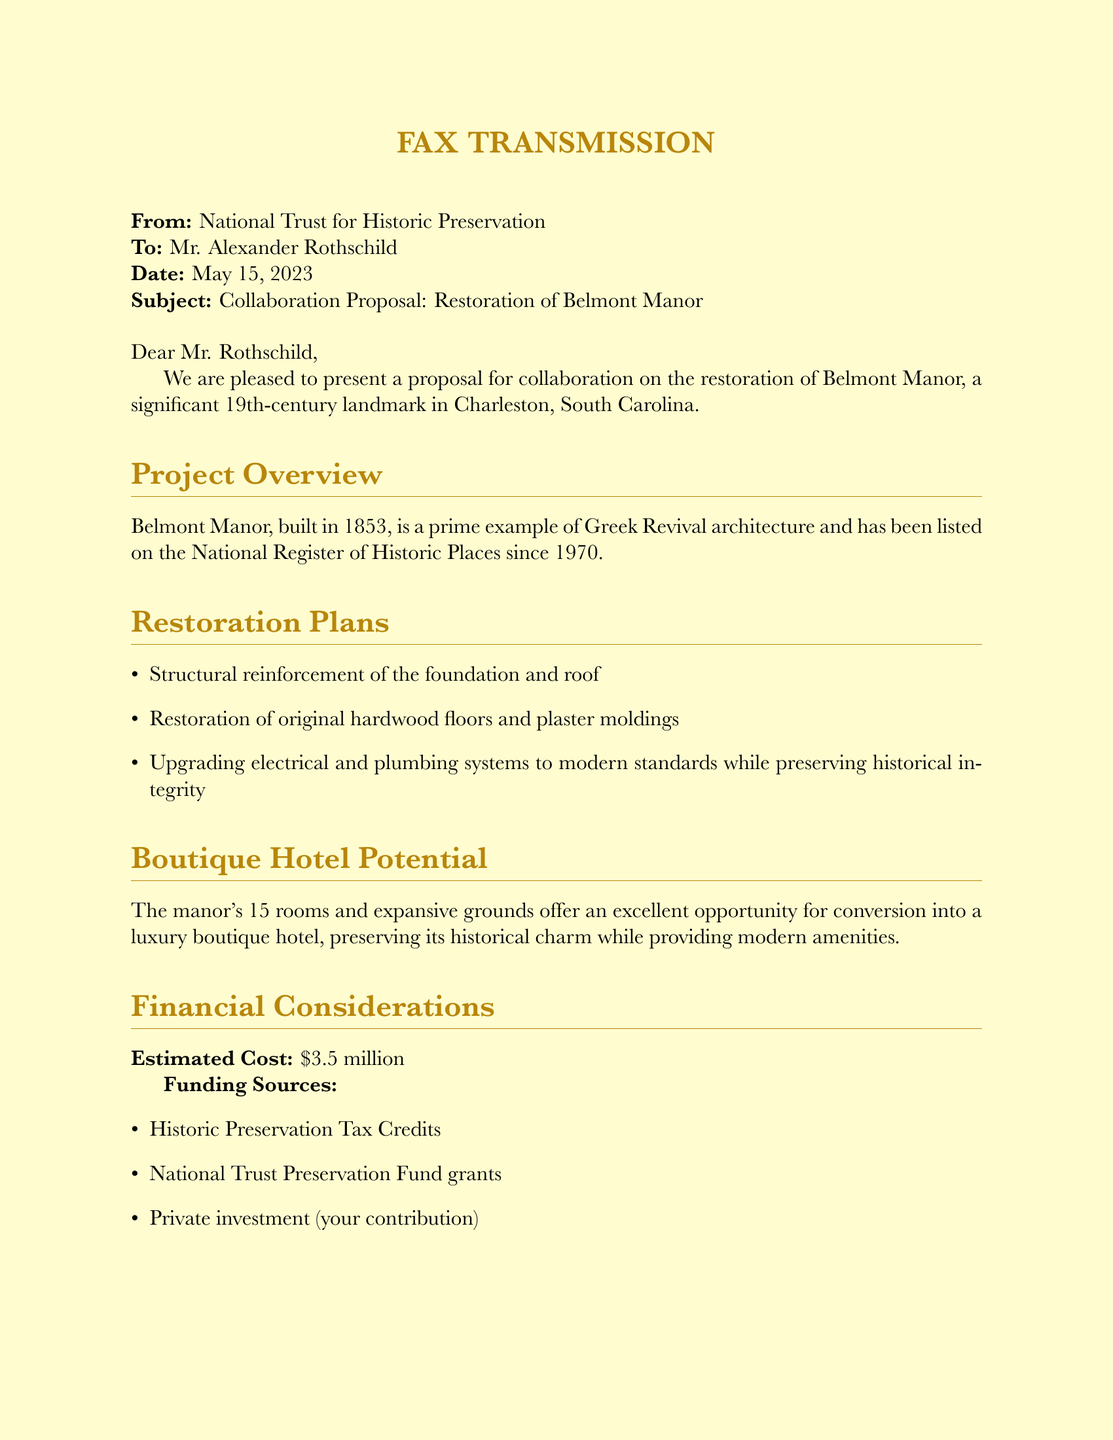What is the date of the fax? The date of the fax is mentioned clearly in the document as May 15, 2023.
Answer: May 15, 2023 Who is the recipient of the fax? The fax is addressed to Mr. Alexander Rothschild, making him the recipient.
Answer: Mr. Alexander Rothschild What is the estimated cost of the project? The document specifies the estimated cost for the restoration of Belmont Manor as $3.5 million.
Answer: $3.5 million What architectural style does Belmont Manor represent? The architectural style of Belmont Manor is described in the document as Greek Revival.
Answer: Greek Revival What is the projected completion timeline for the project? The document states the projected completion timeline is within 18 months from project commencement.
Answer: 18 months What type of hotel is proposed for Belmont Manor? The proposal discusses the conversion of Belmont Manor into a luxury boutique hotel.
Answer: Luxury boutique hotel List one funding source mentioned in the document. The document provides several funding sources, one of which is Historic Preservation Tax Credits.
Answer: Historic Preservation Tax Credits What is one benefit of the proposed project? The benefits listed include the preservation of a significant historical landmark as one of the key advantages.
Answer: Preservation of a significant historical landmark 